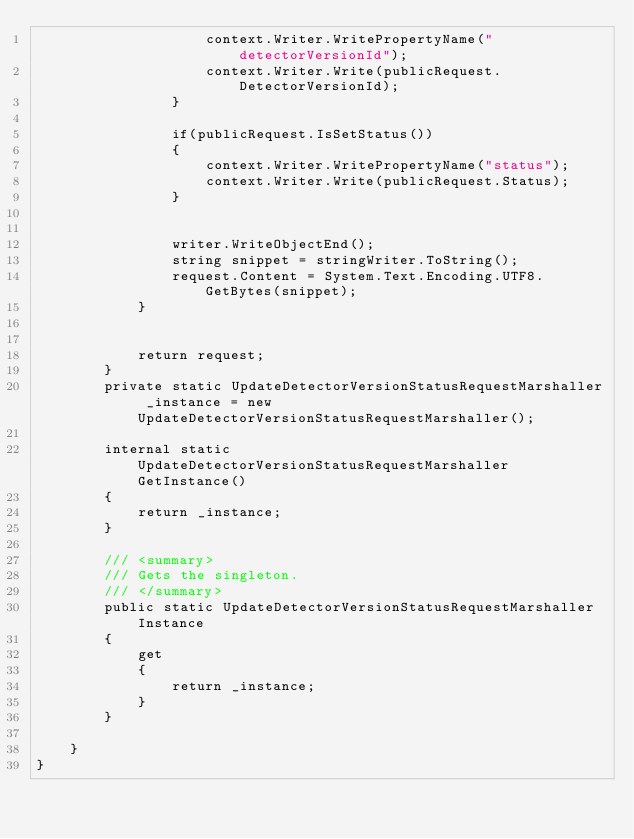<code> <loc_0><loc_0><loc_500><loc_500><_C#_>                    context.Writer.WritePropertyName("detectorVersionId");
                    context.Writer.Write(publicRequest.DetectorVersionId);
                }

                if(publicRequest.IsSetStatus())
                {
                    context.Writer.WritePropertyName("status");
                    context.Writer.Write(publicRequest.Status);
                }

        
                writer.WriteObjectEnd();
                string snippet = stringWriter.ToString();
                request.Content = System.Text.Encoding.UTF8.GetBytes(snippet);
            }


            return request;
        }
        private static UpdateDetectorVersionStatusRequestMarshaller _instance = new UpdateDetectorVersionStatusRequestMarshaller();        

        internal static UpdateDetectorVersionStatusRequestMarshaller GetInstance()
        {
            return _instance;
        }

        /// <summary>
        /// Gets the singleton.
        /// </summary>  
        public static UpdateDetectorVersionStatusRequestMarshaller Instance
        {
            get
            {
                return _instance;
            }
        }

    }
}</code> 